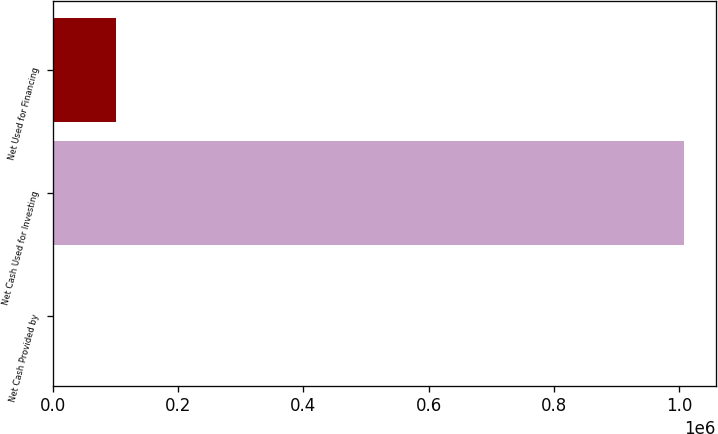Convert chart to OTSL. <chart><loc_0><loc_0><loc_500><loc_500><bar_chart><fcel>Net Cash Provided by<fcel>Net Cash Used for Investing<fcel>Net Used for Financing<nl><fcel>34.6<fcel>1.00733e+06<fcel>100557<nl></chart> 